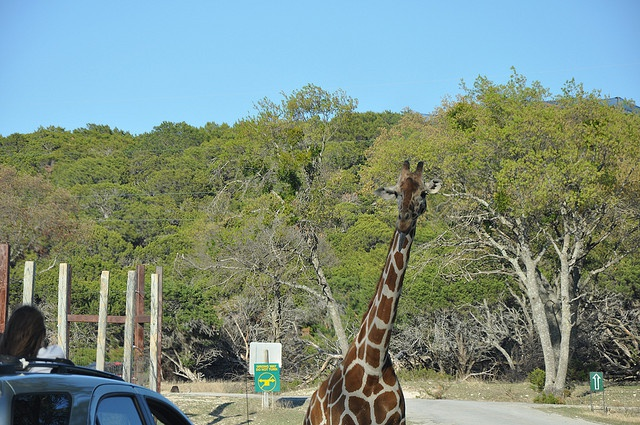Describe the objects in this image and their specific colors. I can see giraffe in lightblue, maroon, black, darkgray, and gray tones, car in lightblue, black, blue, and gray tones, and people in lightblue, black, gray, darkgray, and lightgray tones in this image. 